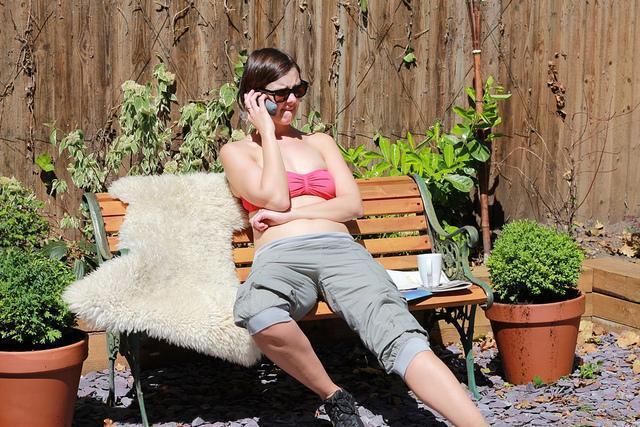How many people are shown?
Give a very brief answer. 1. How many potted plants are there?
Give a very brief answer. 2. How many boats are there?
Give a very brief answer. 0. 